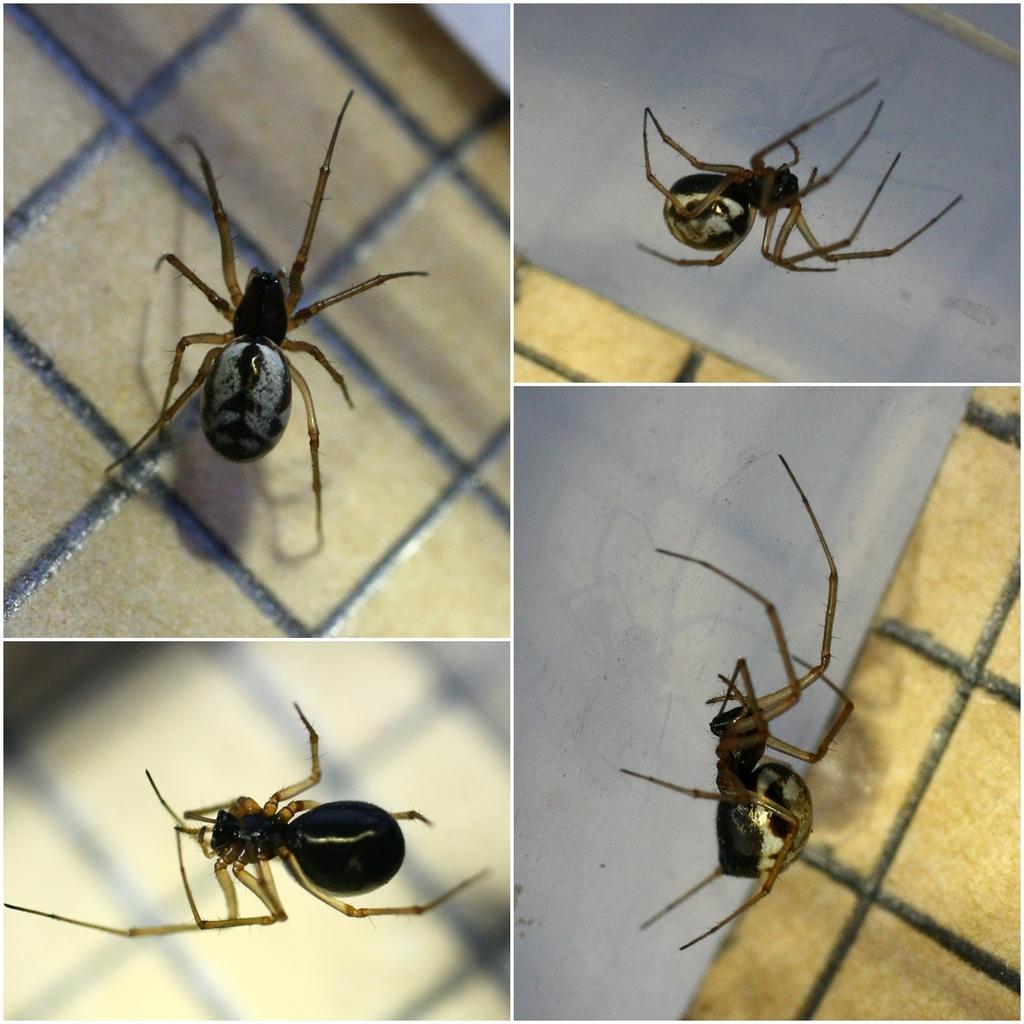How would you summarize this image in a sentence or two? This is a collage. And we can see spider in all images. 